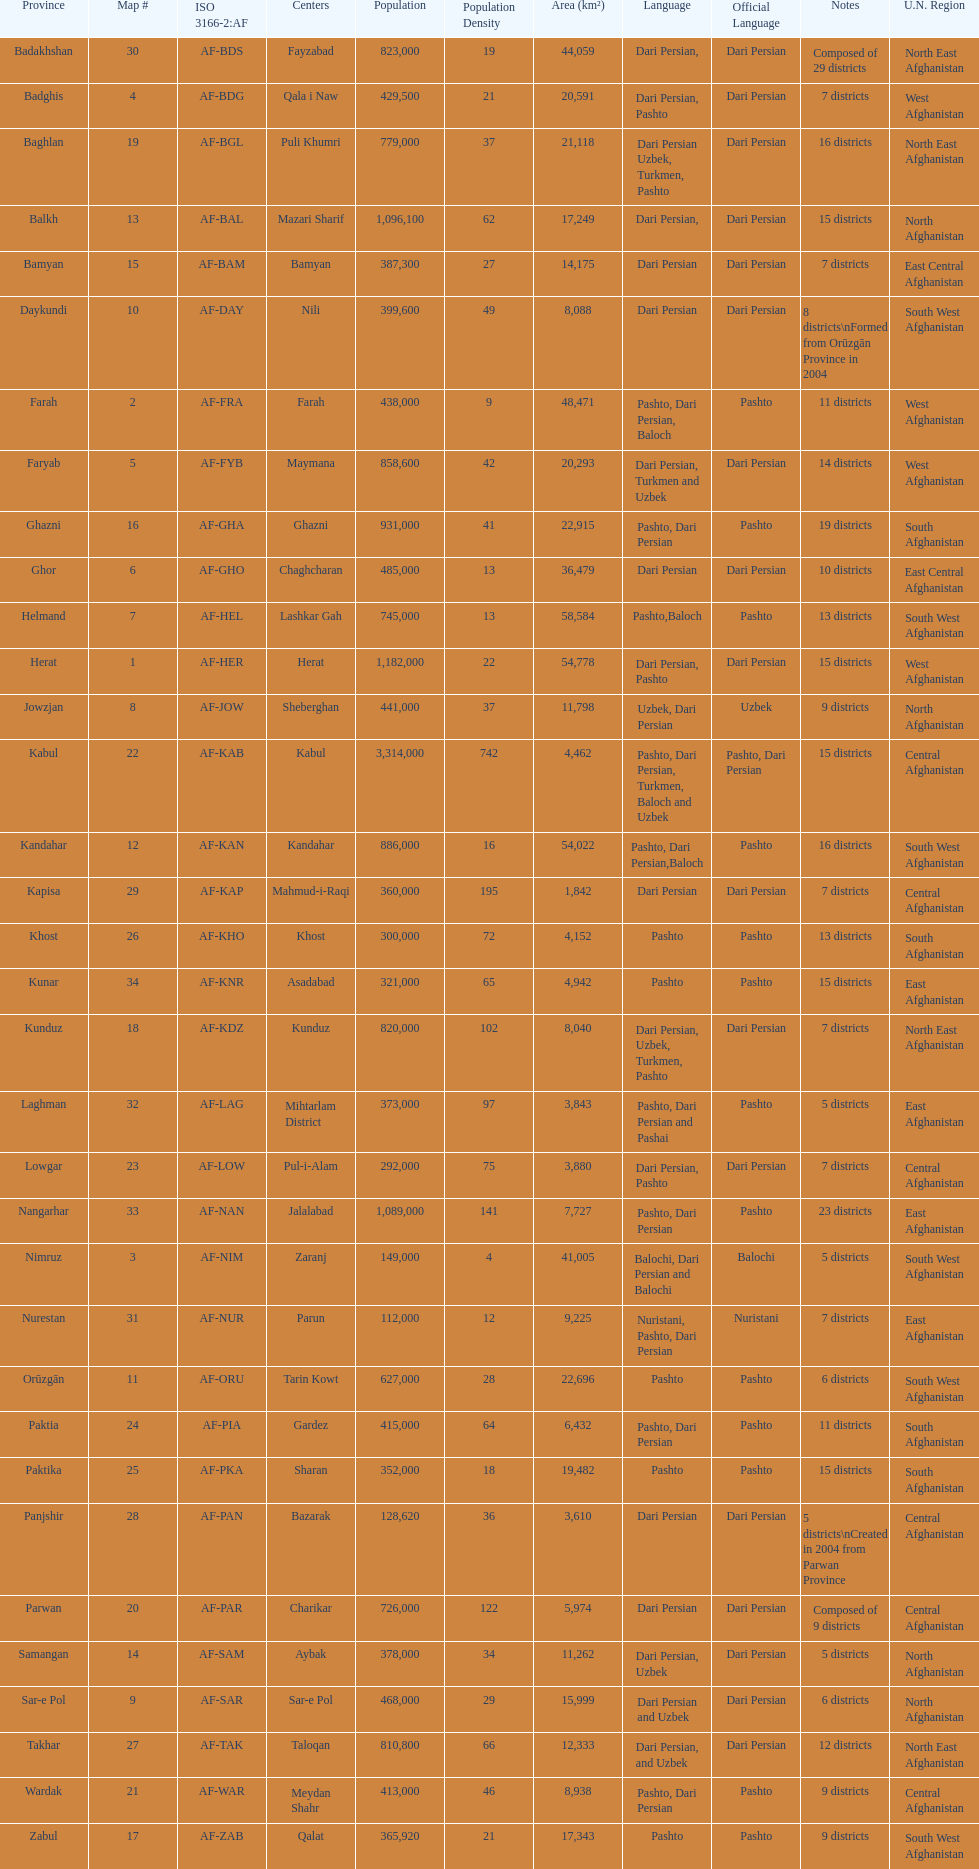How many provinces have pashto as one of their languages 20. 